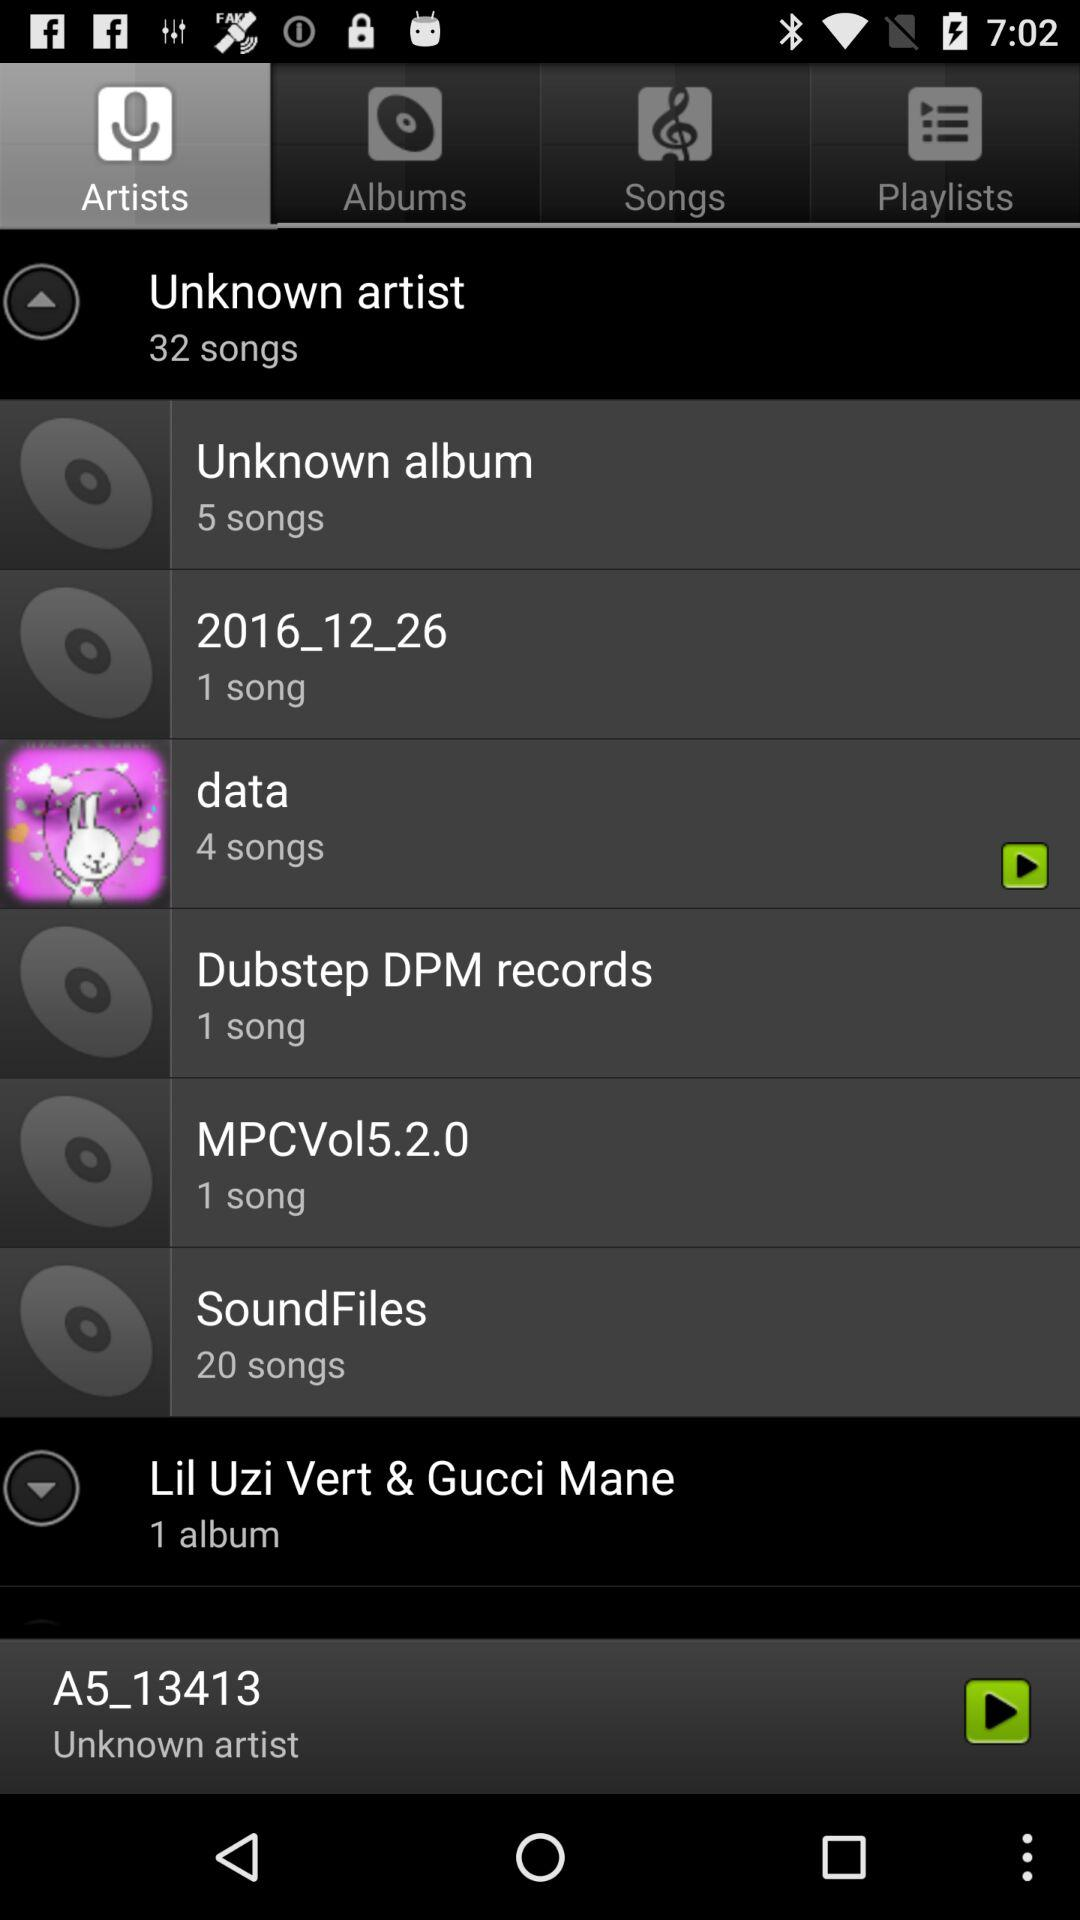How many songs are there in the unknown album? The unknown album contains 5 songs. 